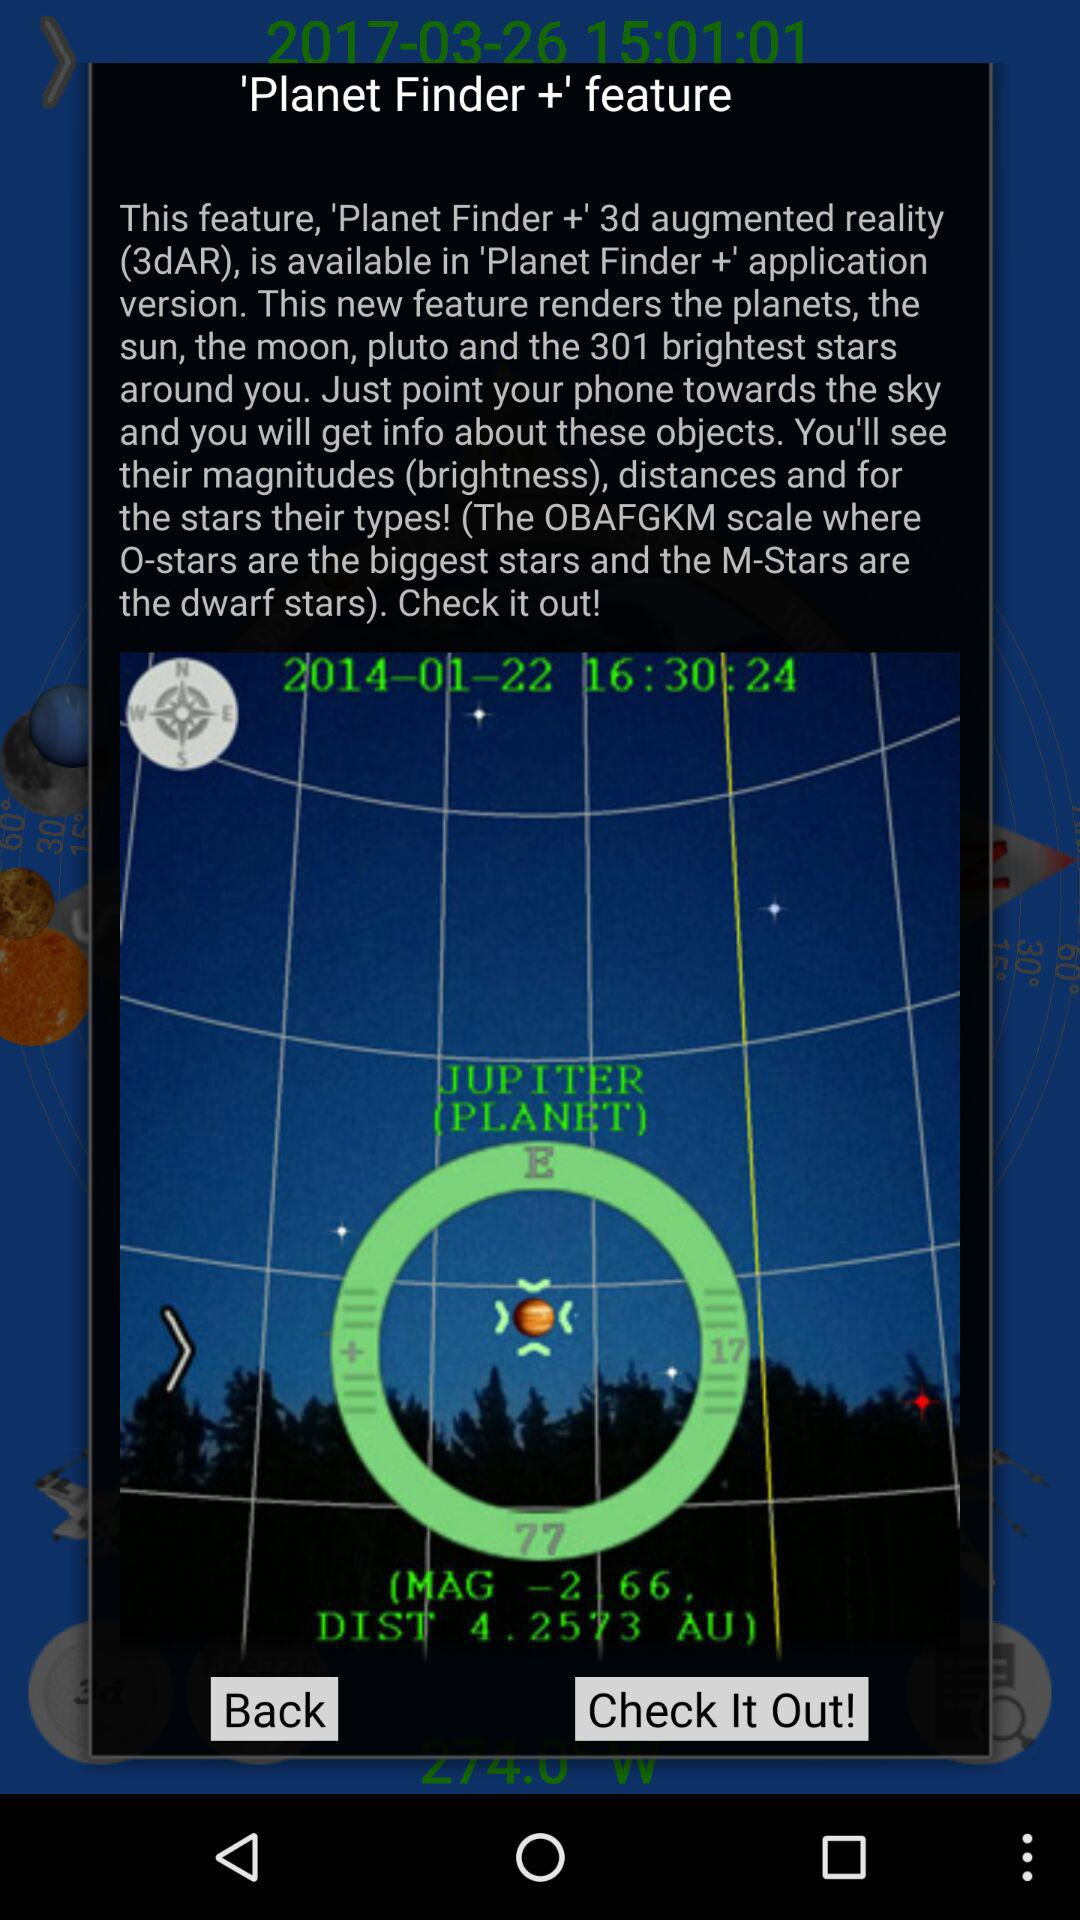What is the name of the feature? The name of the feature is "Planet Finder +". 